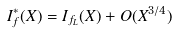<formula> <loc_0><loc_0><loc_500><loc_500>I ^ { \ast } _ { f } ( X ) = I _ { f _ { L } } ( X ) + O ( X ^ { 3 / 4 } )</formula> 